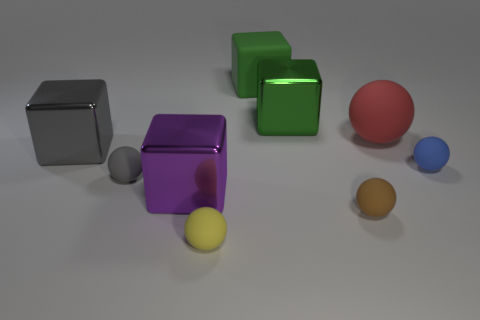Subtract all brown matte balls. How many balls are left? 4 Add 1 tiny green balls. How many objects exist? 10 Subtract all purple blocks. How many blocks are left? 3 Subtract all spheres. How many objects are left? 4 Subtract 4 blocks. How many blocks are left? 0 Subtract all green spheres. Subtract all red blocks. How many spheres are left? 5 Subtract all cyan spheres. How many purple blocks are left? 1 Subtract all gray metallic objects. Subtract all yellow spheres. How many objects are left? 7 Add 5 big green objects. How many big green objects are left? 7 Add 8 blue balls. How many blue balls exist? 9 